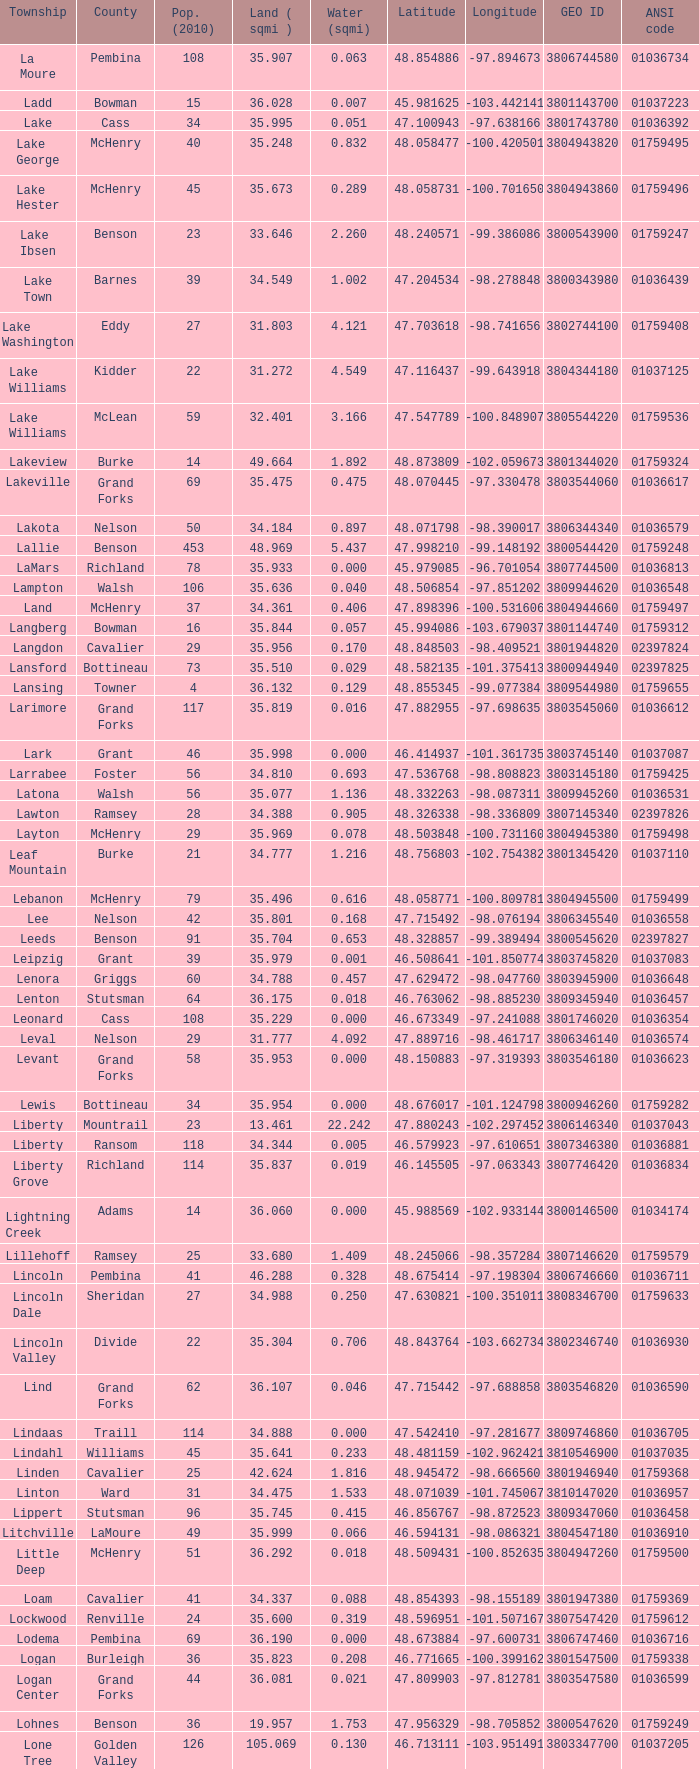Could you parse the entire table as a dict? {'header': ['Township', 'County', 'Pop. (2010)', 'Land ( sqmi )', 'Water (sqmi)', 'Latitude', 'Longitude', 'GEO ID', 'ANSI code'], 'rows': [['La Moure', 'Pembina', '108', '35.907', '0.063', '48.854886', '-97.894673', '3806744580', '01036734'], ['Ladd', 'Bowman', '15', '36.028', '0.007', '45.981625', '-103.442141', '3801143700', '01037223'], ['Lake', 'Cass', '34', '35.995', '0.051', '47.100943', '-97.638166', '3801743780', '01036392'], ['Lake George', 'McHenry', '40', '35.248', '0.832', '48.058477', '-100.420501', '3804943820', '01759495'], ['Lake Hester', 'McHenry', '45', '35.673', '0.289', '48.058731', '-100.701650', '3804943860', '01759496'], ['Lake Ibsen', 'Benson', '23', '33.646', '2.260', '48.240571', '-99.386086', '3800543900', '01759247'], ['Lake Town', 'Barnes', '39', '34.549', '1.002', '47.204534', '-98.278848', '3800343980', '01036439'], ['Lake Washington', 'Eddy', '27', '31.803', '4.121', '47.703618', '-98.741656', '3802744100', '01759408'], ['Lake Williams', 'Kidder', '22', '31.272', '4.549', '47.116437', '-99.643918', '3804344180', '01037125'], ['Lake Williams', 'McLean', '59', '32.401', '3.166', '47.547789', '-100.848907', '3805544220', '01759536'], ['Lakeview', 'Burke', '14', '49.664', '1.892', '48.873809', '-102.059673', '3801344020', '01759324'], ['Lakeville', 'Grand Forks', '69', '35.475', '0.475', '48.070445', '-97.330478', '3803544060', '01036617'], ['Lakota', 'Nelson', '50', '34.184', '0.897', '48.071798', '-98.390017', '3806344340', '01036579'], ['Lallie', 'Benson', '453', '48.969', '5.437', '47.998210', '-99.148192', '3800544420', '01759248'], ['LaMars', 'Richland', '78', '35.933', '0.000', '45.979085', '-96.701054', '3807744500', '01036813'], ['Lampton', 'Walsh', '106', '35.636', '0.040', '48.506854', '-97.851202', '3809944620', '01036548'], ['Land', 'McHenry', '37', '34.361', '0.406', '47.898396', '-100.531606', '3804944660', '01759497'], ['Langberg', 'Bowman', '16', '35.844', '0.057', '45.994086', '-103.679037', '3801144740', '01759312'], ['Langdon', 'Cavalier', '29', '35.956', '0.170', '48.848503', '-98.409521', '3801944820', '02397824'], ['Lansford', 'Bottineau', '73', '35.510', '0.029', '48.582135', '-101.375413', '3800944940', '02397825'], ['Lansing', 'Towner', '4', '36.132', '0.129', '48.855345', '-99.077384', '3809544980', '01759655'], ['Larimore', 'Grand Forks', '117', '35.819', '0.016', '47.882955', '-97.698635', '3803545060', '01036612'], ['Lark', 'Grant', '46', '35.998', '0.000', '46.414937', '-101.361735', '3803745140', '01037087'], ['Larrabee', 'Foster', '56', '34.810', '0.693', '47.536768', '-98.808823', '3803145180', '01759425'], ['Latona', 'Walsh', '56', '35.077', '1.136', '48.332263', '-98.087311', '3809945260', '01036531'], ['Lawton', 'Ramsey', '28', '34.388', '0.905', '48.326338', '-98.336809', '3807145340', '02397826'], ['Layton', 'McHenry', '29', '35.969', '0.078', '48.503848', '-100.731160', '3804945380', '01759498'], ['Leaf Mountain', 'Burke', '21', '34.777', '1.216', '48.756803', '-102.754382', '3801345420', '01037110'], ['Lebanon', 'McHenry', '79', '35.496', '0.616', '48.058771', '-100.809781', '3804945500', '01759499'], ['Lee', 'Nelson', '42', '35.801', '0.168', '47.715492', '-98.076194', '3806345540', '01036558'], ['Leeds', 'Benson', '91', '35.704', '0.653', '48.328857', '-99.389494', '3800545620', '02397827'], ['Leipzig', 'Grant', '39', '35.979', '0.001', '46.508641', '-101.850774', '3803745820', '01037083'], ['Lenora', 'Griggs', '60', '34.788', '0.457', '47.629472', '-98.047760', '3803945900', '01036648'], ['Lenton', 'Stutsman', '64', '36.175', '0.018', '46.763062', '-98.885230', '3809345940', '01036457'], ['Leonard', 'Cass', '108', '35.229', '0.000', '46.673349', '-97.241088', '3801746020', '01036354'], ['Leval', 'Nelson', '29', '31.777', '4.092', '47.889716', '-98.461717', '3806346140', '01036574'], ['Levant', 'Grand Forks', '58', '35.953', '0.000', '48.150883', '-97.319393', '3803546180', '01036623'], ['Lewis', 'Bottineau', '34', '35.954', '0.000', '48.676017', '-101.124798', '3800946260', '01759282'], ['Liberty', 'Mountrail', '23', '13.461', '22.242', '47.880243', '-102.297452', '3806146340', '01037043'], ['Liberty', 'Ransom', '118', '34.344', '0.005', '46.579923', '-97.610651', '3807346380', '01036881'], ['Liberty Grove', 'Richland', '114', '35.837', '0.019', '46.145505', '-97.063343', '3807746420', '01036834'], ['Lightning Creek', 'Adams', '14', '36.060', '0.000', '45.988569', '-102.933144', '3800146500', '01034174'], ['Lillehoff', 'Ramsey', '25', '33.680', '1.409', '48.245066', '-98.357284', '3807146620', '01759579'], ['Lincoln', 'Pembina', '41', '46.288', '0.328', '48.675414', '-97.198304', '3806746660', '01036711'], ['Lincoln Dale', 'Sheridan', '27', '34.988', '0.250', '47.630821', '-100.351011', '3808346700', '01759633'], ['Lincoln Valley', 'Divide', '22', '35.304', '0.706', '48.843764', '-103.662734', '3802346740', '01036930'], ['Lind', 'Grand Forks', '62', '36.107', '0.046', '47.715442', '-97.688858', '3803546820', '01036590'], ['Lindaas', 'Traill', '114', '34.888', '0.000', '47.542410', '-97.281677', '3809746860', '01036705'], ['Lindahl', 'Williams', '45', '35.641', '0.233', '48.481159', '-102.962421', '3810546900', '01037035'], ['Linden', 'Cavalier', '25', '42.624', '1.816', '48.945472', '-98.666560', '3801946940', '01759368'], ['Linton', 'Ward', '31', '34.475', '1.533', '48.071039', '-101.745067', '3810147020', '01036957'], ['Lippert', 'Stutsman', '96', '35.745', '0.415', '46.856767', '-98.872523', '3809347060', '01036458'], ['Litchville', 'LaMoure', '49', '35.999', '0.066', '46.594131', '-98.086321', '3804547180', '01036910'], ['Little Deep', 'McHenry', '51', '36.292', '0.018', '48.509431', '-100.852635', '3804947260', '01759500'], ['Loam', 'Cavalier', '41', '34.337', '0.088', '48.854393', '-98.155189', '3801947380', '01759369'], ['Lockwood', 'Renville', '24', '35.600', '0.319', '48.596951', '-101.507167', '3807547420', '01759612'], ['Lodema', 'Pembina', '69', '36.190', '0.000', '48.673884', '-97.600731', '3806747460', '01036716'], ['Logan', 'Burleigh', '36', '35.823', '0.208', '46.771665', '-100.399162', '3801547500', '01759338'], ['Logan Center', 'Grand Forks', '44', '36.081', '0.021', '47.809903', '-97.812781', '3803547580', '01036599'], ['Lohnes', 'Benson', '36', '19.957', '1.753', '47.956329', '-98.705852', '3800547620', '01759249'], ['Lone Tree', 'Golden Valley', '126', '105.069', '0.130', '46.713111', '-103.951491', '3803347700', '01037205'], ['Long Creek', 'Divide', '37', '42.592', '0.903', '48.944096', '-103.126212', '3802347780', '01759393'], ['Long Lake', 'Burleigh', '103', '32.246', '3.787', '46.671655', '-100.275198', '3801547860', '01037067'], ['Longfellow', 'McLean', '38', '36.091', '0.054', '47.451742', '-101.254669', '3805547820', '01759537'], ['Longview', 'Foster', '47', '35.364', '0.753', '47.365433', '-99.207755', '3803147900', '01037138'], ['Loquemont', 'McLean', '62', '35.901', '0.041', '47.710140', '-102.075634', '3805547940', '01759538'], ['Lordsburg', 'Bottineau', '19', '35.341', '0.825', '48.769624', '-100.228663', '3800948060', '01759283'], ['Loretta', 'Grand Forks', '50', '36.138', '0.000', '47.715705', '-97.817996', '3803548100', '01036591'], ['Lorraine', 'Dickey', '35', '35.611', '0.028', '45.986327', '-98.824337', '3802148140', '01036749'], ['Lostwood', 'Mountrail', '40', '34.276', '1.569', '48.503029', '-102.419021', '3806148220', '01037117'], ['Lovell', 'Dickey', '42', '43.572', '0.484', '45.979477', '-98.080806', '3802148260', '01036742'], ['Lowery', 'Stutsman', '33', '34.212', '1.111', '47.285621', '-99.424886', '3809348300', '01037187'], ['Lowland', 'Mountrail', '52', '34.469', '1.610', '48.506983', '-102.025237', '3806148340', '01036980'], ['Lucy', 'Burke', '27', '34.394', '1.692', '48.690915', '-102.549425', '3801348420', '01759325'], ['Lund', 'Ward', '50', '34.796', '1.204', '48.059167', '-101.846052', '3810148500', '01036940'], ['Lynn', 'Wells', '21', '34.710', '1.455', '47.370988', '-99.979621', '3810348660', '01037155'], ['Lyon', 'Stutsman', '19', '33.030', '2.818', '47.195251', '-98.784930', '3809348740', '01036500']]} 319? None. 